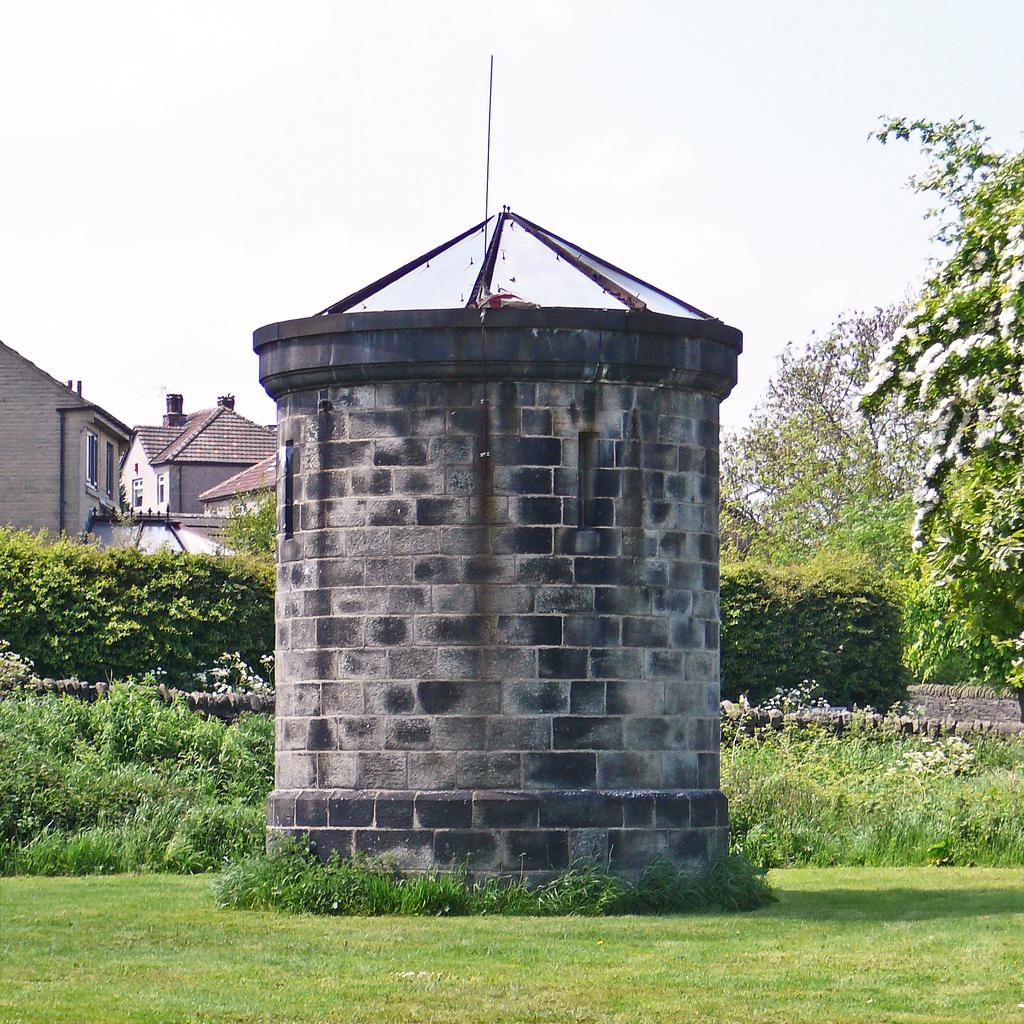What type of structures can be seen in the image? There are houses in the image. What type of vegetation is present in the image? There are plants, trees, grass, and flowers in the image. What is the large object in the image? There is a tank in the image. What is visible in the background of the image? The sky is visible in the image. What type of string is used to hold up the apparel in the image? There is no string or apparel present in the image. What type of jam is being served with the flowers in the image? There is no jam present in the image; it features houses, plants, trees, grass, flowers, a tank, and the sky. 